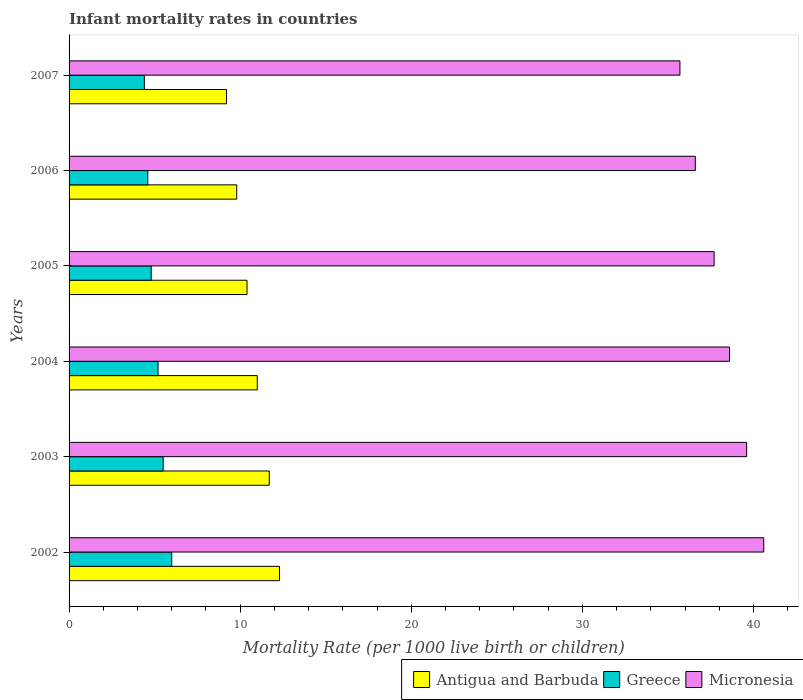Are the number of bars per tick equal to the number of legend labels?
Give a very brief answer. Yes. How many bars are there on the 1st tick from the bottom?
Give a very brief answer. 3. What is the label of the 2nd group of bars from the top?
Give a very brief answer. 2006. In how many cases, is the number of bars for a given year not equal to the number of legend labels?
Make the answer very short. 0. Across all years, what is the minimum infant mortality rate in Micronesia?
Offer a very short reply. 35.7. What is the total infant mortality rate in Greece in the graph?
Your answer should be compact. 30.5. What is the difference between the infant mortality rate in Micronesia in 2003 and that in 2005?
Your response must be concise. 1.9. What is the difference between the infant mortality rate in Antigua and Barbuda in 2004 and the infant mortality rate in Micronesia in 2002?
Provide a short and direct response. -29.6. What is the average infant mortality rate in Greece per year?
Your response must be concise. 5.08. In the year 2002, what is the difference between the infant mortality rate in Antigua and Barbuda and infant mortality rate in Greece?
Your response must be concise. 6.3. In how many years, is the infant mortality rate in Antigua and Barbuda greater than 2 ?
Provide a short and direct response. 6. What is the ratio of the infant mortality rate in Micronesia in 2004 to that in 2005?
Provide a succinct answer. 1.02. Is the difference between the infant mortality rate in Antigua and Barbuda in 2003 and 2006 greater than the difference between the infant mortality rate in Greece in 2003 and 2006?
Your answer should be compact. Yes. What is the difference between the highest and the second highest infant mortality rate in Greece?
Your answer should be very brief. 0.5. What is the difference between the highest and the lowest infant mortality rate in Greece?
Offer a terse response. 1.6. What does the 1st bar from the top in 2002 represents?
Give a very brief answer. Micronesia. What does the 3rd bar from the bottom in 2005 represents?
Your answer should be very brief. Micronesia. How many bars are there?
Give a very brief answer. 18. How many years are there in the graph?
Give a very brief answer. 6. What is the difference between two consecutive major ticks on the X-axis?
Make the answer very short. 10. Are the values on the major ticks of X-axis written in scientific E-notation?
Ensure brevity in your answer.  No. Does the graph contain any zero values?
Provide a succinct answer. No. Does the graph contain grids?
Your response must be concise. No. How many legend labels are there?
Provide a short and direct response. 3. How are the legend labels stacked?
Keep it short and to the point. Horizontal. What is the title of the graph?
Ensure brevity in your answer.  Infant mortality rates in countries. Does "Qatar" appear as one of the legend labels in the graph?
Your answer should be very brief. No. What is the label or title of the X-axis?
Offer a very short reply. Mortality Rate (per 1000 live birth or children). What is the Mortality Rate (per 1000 live birth or children) in Antigua and Barbuda in 2002?
Your answer should be very brief. 12.3. What is the Mortality Rate (per 1000 live birth or children) of Micronesia in 2002?
Provide a short and direct response. 40.6. What is the Mortality Rate (per 1000 live birth or children) in Antigua and Barbuda in 2003?
Your answer should be very brief. 11.7. What is the Mortality Rate (per 1000 live birth or children) of Greece in 2003?
Keep it short and to the point. 5.5. What is the Mortality Rate (per 1000 live birth or children) of Micronesia in 2003?
Make the answer very short. 39.6. What is the Mortality Rate (per 1000 live birth or children) of Antigua and Barbuda in 2004?
Offer a very short reply. 11. What is the Mortality Rate (per 1000 live birth or children) of Micronesia in 2004?
Provide a succinct answer. 38.6. What is the Mortality Rate (per 1000 live birth or children) of Antigua and Barbuda in 2005?
Provide a short and direct response. 10.4. What is the Mortality Rate (per 1000 live birth or children) of Greece in 2005?
Provide a succinct answer. 4.8. What is the Mortality Rate (per 1000 live birth or children) in Micronesia in 2005?
Give a very brief answer. 37.7. What is the Mortality Rate (per 1000 live birth or children) in Micronesia in 2006?
Provide a short and direct response. 36.6. What is the Mortality Rate (per 1000 live birth or children) in Antigua and Barbuda in 2007?
Offer a very short reply. 9.2. What is the Mortality Rate (per 1000 live birth or children) in Greece in 2007?
Ensure brevity in your answer.  4.4. What is the Mortality Rate (per 1000 live birth or children) in Micronesia in 2007?
Give a very brief answer. 35.7. Across all years, what is the maximum Mortality Rate (per 1000 live birth or children) in Antigua and Barbuda?
Offer a very short reply. 12.3. Across all years, what is the maximum Mortality Rate (per 1000 live birth or children) in Greece?
Offer a terse response. 6. Across all years, what is the maximum Mortality Rate (per 1000 live birth or children) of Micronesia?
Provide a succinct answer. 40.6. Across all years, what is the minimum Mortality Rate (per 1000 live birth or children) in Micronesia?
Ensure brevity in your answer.  35.7. What is the total Mortality Rate (per 1000 live birth or children) of Antigua and Barbuda in the graph?
Provide a short and direct response. 64.4. What is the total Mortality Rate (per 1000 live birth or children) in Greece in the graph?
Your response must be concise. 30.5. What is the total Mortality Rate (per 1000 live birth or children) in Micronesia in the graph?
Offer a terse response. 228.8. What is the difference between the Mortality Rate (per 1000 live birth or children) of Antigua and Barbuda in 2002 and that in 2003?
Your answer should be compact. 0.6. What is the difference between the Mortality Rate (per 1000 live birth or children) of Greece in 2002 and that in 2003?
Offer a very short reply. 0.5. What is the difference between the Mortality Rate (per 1000 live birth or children) of Micronesia in 2002 and that in 2003?
Your response must be concise. 1. What is the difference between the Mortality Rate (per 1000 live birth or children) in Greece in 2002 and that in 2004?
Give a very brief answer. 0.8. What is the difference between the Mortality Rate (per 1000 live birth or children) of Micronesia in 2002 and that in 2004?
Give a very brief answer. 2. What is the difference between the Mortality Rate (per 1000 live birth or children) in Antigua and Barbuda in 2002 and that in 2005?
Provide a short and direct response. 1.9. What is the difference between the Mortality Rate (per 1000 live birth or children) in Greece in 2002 and that in 2006?
Keep it short and to the point. 1.4. What is the difference between the Mortality Rate (per 1000 live birth or children) of Micronesia in 2002 and that in 2006?
Offer a very short reply. 4. What is the difference between the Mortality Rate (per 1000 live birth or children) of Antigua and Barbuda in 2002 and that in 2007?
Ensure brevity in your answer.  3.1. What is the difference between the Mortality Rate (per 1000 live birth or children) in Greece in 2002 and that in 2007?
Offer a terse response. 1.6. What is the difference between the Mortality Rate (per 1000 live birth or children) of Micronesia in 2002 and that in 2007?
Offer a terse response. 4.9. What is the difference between the Mortality Rate (per 1000 live birth or children) in Greece in 2003 and that in 2004?
Give a very brief answer. 0.3. What is the difference between the Mortality Rate (per 1000 live birth or children) of Micronesia in 2003 and that in 2004?
Provide a succinct answer. 1. What is the difference between the Mortality Rate (per 1000 live birth or children) of Greece in 2003 and that in 2007?
Give a very brief answer. 1.1. What is the difference between the Mortality Rate (per 1000 live birth or children) in Micronesia in 2004 and that in 2005?
Ensure brevity in your answer.  0.9. What is the difference between the Mortality Rate (per 1000 live birth or children) of Antigua and Barbuda in 2004 and that in 2006?
Make the answer very short. 1.2. What is the difference between the Mortality Rate (per 1000 live birth or children) of Micronesia in 2004 and that in 2006?
Make the answer very short. 2. What is the difference between the Mortality Rate (per 1000 live birth or children) of Antigua and Barbuda in 2004 and that in 2007?
Ensure brevity in your answer.  1.8. What is the difference between the Mortality Rate (per 1000 live birth or children) in Micronesia in 2004 and that in 2007?
Make the answer very short. 2.9. What is the difference between the Mortality Rate (per 1000 live birth or children) in Antigua and Barbuda in 2005 and that in 2006?
Your answer should be compact. 0.6. What is the difference between the Mortality Rate (per 1000 live birth or children) in Micronesia in 2005 and that in 2006?
Offer a terse response. 1.1. What is the difference between the Mortality Rate (per 1000 live birth or children) in Antigua and Barbuda in 2006 and that in 2007?
Give a very brief answer. 0.6. What is the difference between the Mortality Rate (per 1000 live birth or children) in Greece in 2006 and that in 2007?
Provide a succinct answer. 0.2. What is the difference between the Mortality Rate (per 1000 live birth or children) of Micronesia in 2006 and that in 2007?
Your response must be concise. 0.9. What is the difference between the Mortality Rate (per 1000 live birth or children) of Antigua and Barbuda in 2002 and the Mortality Rate (per 1000 live birth or children) of Greece in 2003?
Your answer should be compact. 6.8. What is the difference between the Mortality Rate (per 1000 live birth or children) of Antigua and Barbuda in 2002 and the Mortality Rate (per 1000 live birth or children) of Micronesia in 2003?
Ensure brevity in your answer.  -27.3. What is the difference between the Mortality Rate (per 1000 live birth or children) of Greece in 2002 and the Mortality Rate (per 1000 live birth or children) of Micronesia in 2003?
Provide a short and direct response. -33.6. What is the difference between the Mortality Rate (per 1000 live birth or children) in Antigua and Barbuda in 2002 and the Mortality Rate (per 1000 live birth or children) in Micronesia in 2004?
Provide a short and direct response. -26.3. What is the difference between the Mortality Rate (per 1000 live birth or children) in Greece in 2002 and the Mortality Rate (per 1000 live birth or children) in Micronesia in 2004?
Your answer should be very brief. -32.6. What is the difference between the Mortality Rate (per 1000 live birth or children) in Antigua and Barbuda in 2002 and the Mortality Rate (per 1000 live birth or children) in Greece in 2005?
Your answer should be compact. 7.5. What is the difference between the Mortality Rate (per 1000 live birth or children) in Antigua and Barbuda in 2002 and the Mortality Rate (per 1000 live birth or children) in Micronesia in 2005?
Make the answer very short. -25.4. What is the difference between the Mortality Rate (per 1000 live birth or children) of Greece in 2002 and the Mortality Rate (per 1000 live birth or children) of Micronesia in 2005?
Provide a short and direct response. -31.7. What is the difference between the Mortality Rate (per 1000 live birth or children) in Antigua and Barbuda in 2002 and the Mortality Rate (per 1000 live birth or children) in Micronesia in 2006?
Give a very brief answer. -24.3. What is the difference between the Mortality Rate (per 1000 live birth or children) of Greece in 2002 and the Mortality Rate (per 1000 live birth or children) of Micronesia in 2006?
Give a very brief answer. -30.6. What is the difference between the Mortality Rate (per 1000 live birth or children) of Antigua and Barbuda in 2002 and the Mortality Rate (per 1000 live birth or children) of Greece in 2007?
Make the answer very short. 7.9. What is the difference between the Mortality Rate (per 1000 live birth or children) in Antigua and Barbuda in 2002 and the Mortality Rate (per 1000 live birth or children) in Micronesia in 2007?
Make the answer very short. -23.4. What is the difference between the Mortality Rate (per 1000 live birth or children) of Greece in 2002 and the Mortality Rate (per 1000 live birth or children) of Micronesia in 2007?
Keep it short and to the point. -29.7. What is the difference between the Mortality Rate (per 1000 live birth or children) in Antigua and Barbuda in 2003 and the Mortality Rate (per 1000 live birth or children) in Micronesia in 2004?
Your answer should be very brief. -26.9. What is the difference between the Mortality Rate (per 1000 live birth or children) in Greece in 2003 and the Mortality Rate (per 1000 live birth or children) in Micronesia in 2004?
Your answer should be very brief. -33.1. What is the difference between the Mortality Rate (per 1000 live birth or children) in Greece in 2003 and the Mortality Rate (per 1000 live birth or children) in Micronesia in 2005?
Make the answer very short. -32.2. What is the difference between the Mortality Rate (per 1000 live birth or children) in Antigua and Barbuda in 2003 and the Mortality Rate (per 1000 live birth or children) in Greece in 2006?
Offer a terse response. 7.1. What is the difference between the Mortality Rate (per 1000 live birth or children) in Antigua and Barbuda in 2003 and the Mortality Rate (per 1000 live birth or children) in Micronesia in 2006?
Keep it short and to the point. -24.9. What is the difference between the Mortality Rate (per 1000 live birth or children) of Greece in 2003 and the Mortality Rate (per 1000 live birth or children) of Micronesia in 2006?
Provide a succinct answer. -31.1. What is the difference between the Mortality Rate (per 1000 live birth or children) in Antigua and Barbuda in 2003 and the Mortality Rate (per 1000 live birth or children) in Micronesia in 2007?
Make the answer very short. -24. What is the difference between the Mortality Rate (per 1000 live birth or children) in Greece in 2003 and the Mortality Rate (per 1000 live birth or children) in Micronesia in 2007?
Provide a short and direct response. -30.2. What is the difference between the Mortality Rate (per 1000 live birth or children) in Antigua and Barbuda in 2004 and the Mortality Rate (per 1000 live birth or children) in Micronesia in 2005?
Provide a short and direct response. -26.7. What is the difference between the Mortality Rate (per 1000 live birth or children) in Greece in 2004 and the Mortality Rate (per 1000 live birth or children) in Micronesia in 2005?
Keep it short and to the point. -32.5. What is the difference between the Mortality Rate (per 1000 live birth or children) of Antigua and Barbuda in 2004 and the Mortality Rate (per 1000 live birth or children) of Micronesia in 2006?
Offer a terse response. -25.6. What is the difference between the Mortality Rate (per 1000 live birth or children) of Greece in 2004 and the Mortality Rate (per 1000 live birth or children) of Micronesia in 2006?
Your response must be concise. -31.4. What is the difference between the Mortality Rate (per 1000 live birth or children) of Antigua and Barbuda in 2004 and the Mortality Rate (per 1000 live birth or children) of Greece in 2007?
Your answer should be very brief. 6.6. What is the difference between the Mortality Rate (per 1000 live birth or children) of Antigua and Barbuda in 2004 and the Mortality Rate (per 1000 live birth or children) of Micronesia in 2007?
Offer a terse response. -24.7. What is the difference between the Mortality Rate (per 1000 live birth or children) in Greece in 2004 and the Mortality Rate (per 1000 live birth or children) in Micronesia in 2007?
Offer a very short reply. -30.5. What is the difference between the Mortality Rate (per 1000 live birth or children) in Antigua and Barbuda in 2005 and the Mortality Rate (per 1000 live birth or children) in Micronesia in 2006?
Give a very brief answer. -26.2. What is the difference between the Mortality Rate (per 1000 live birth or children) of Greece in 2005 and the Mortality Rate (per 1000 live birth or children) of Micronesia in 2006?
Offer a very short reply. -31.8. What is the difference between the Mortality Rate (per 1000 live birth or children) in Antigua and Barbuda in 2005 and the Mortality Rate (per 1000 live birth or children) in Micronesia in 2007?
Offer a terse response. -25.3. What is the difference between the Mortality Rate (per 1000 live birth or children) of Greece in 2005 and the Mortality Rate (per 1000 live birth or children) of Micronesia in 2007?
Give a very brief answer. -30.9. What is the difference between the Mortality Rate (per 1000 live birth or children) of Antigua and Barbuda in 2006 and the Mortality Rate (per 1000 live birth or children) of Micronesia in 2007?
Offer a terse response. -25.9. What is the difference between the Mortality Rate (per 1000 live birth or children) of Greece in 2006 and the Mortality Rate (per 1000 live birth or children) of Micronesia in 2007?
Keep it short and to the point. -31.1. What is the average Mortality Rate (per 1000 live birth or children) in Antigua and Barbuda per year?
Provide a short and direct response. 10.73. What is the average Mortality Rate (per 1000 live birth or children) of Greece per year?
Keep it short and to the point. 5.08. What is the average Mortality Rate (per 1000 live birth or children) in Micronesia per year?
Your answer should be very brief. 38.13. In the year 2002, what is the difference between the Mortality Rate (per 1000 live birth or children) in Antigua and Barbuda and Mortality Rate (per 1000 live birth or children) in Micronesia?
Give a very brief answer. -28.3. In the year 2002, what is the difference between the Mortality Rate (per 1000 live birth or children) in Greece and Mortality Rate (per 1000 live birth or children) in Micronesia?
Ensure brevity in your answer.  -34.6. In the year 2003, what is the difference between the Mortality Rate (per 1000 live birth or children) of Antigua and Barbuda and Mortality Rate (per 1000 live birth or children) of Greece?
Make the answer very short. 6.2. In the year 2003, what is the difference between the Mortality Rate (per 1000 live birth or children) in Antigua and Barbuda and Mortality Rate (per 1000 live birth or children) in Micronesia?
Offer a very short reply. -27.9. In the year 2003, what is the difference between the Mortality Rate (per 1000 live birth or children) of Greece and Mortality Rate (per 1000 live birth or children) of Micronesia?
Give a very brief answer. -34.1. In the year 2004, what is the difference between the Mortality Rate (per 1000 live birth or children) of Antigua and Barbuda and Mortality Rate (per 1000 live birth or children) of Greece?
Ensure brevity in your answer.  5.8. In the year 2004, what is the difference between the Mortality Rate (per 1000 live birth or children) of Antigua and Barbuda and Mortality Rate (per 1000 live birth or children) of Micronesia?
Offer a very short reply. -27.6. In the year 2004, what is the difference between the Mortality Rate (per 1000 live birth or children) of Greece and Mortality Rate (per 1000 live birth or children) of Micronesia?
Ensure brevity in your answer.  -33.4. In the year 2005, what is the difference between the Mortality Rate (per 1000 live birth or children) of Antigua and Barbuda and Mortality Rate (per 1000 live birth or children) of Micronesia?
Your answer should be very brief. -27.3. In the year 2005, what is the difference between the Mortality Rate (per 1000 live birth or children) in Greece and Mortality Rate (per 1000 live birth or children) in Micronesia?
Make the answer very short. -32.9. In the year 2006, what is the difference between the Mortality Rate (per 1000 live birth or children) of Antigua and Barbuda and Mortality Rate (per 1000 live birth or children) of Greece?
Your response must be concise. 5.2. In the year 2006, what is the difference between the Mortality Rate (per 1000 live birth or children) of Antigua and Barbuda and Mortality Rate (per 1000 live birth or children) of Micronesia?
Your answer should be compact. -26.8. In the year 2006, what is the difference between the Mortality Rate (per 1000 live birth or children) in Greece and Mortality Rate (per 1000 live birth or children) in Micronesia?
Your answer should be very brief. -32. In the year 2007, what is the difference between the Mortality Rate (per 1000 live birth or children) of Antigua and Barbuda and Mortality Rate (per 1000 live birth or children) of Micronesia?
Make the answer very short. -26.5. In the year 2007, what is the difference between the Mortality Rate (per 1000 live birth or children) in Greece and Mortality Rate (per 1000 live birth or children) in Micronesia?
Your response must be concise. -31.3. What is the ratio of the Mortality Rate (per 1000 live birth or children) of Antigua and Barbuda in 2002 to that in 2003?
Your answer should be compact. 1.05. What is the ratio of the Mortality Rate (per 1000 live birth or children) of Micronesia in 2002 to that in 2003?
Make the answer very short. 1.03. What is the ratio of the Mortality Rate (per 1000 live birth or children) in Antigua and Barbuda in 2002 to that in 2004?
Make the answer very short. 1.12. What is the ratio of the Mortality Rate (per 1000 live birth or children) of Greece in 2002 to that in 2004?
Your response must be concise. 1.15. What is the ratio of the Mortality Rate (per 1000 live birth or children) in Micronesia in 2002 to that in 2004?
Offer a very short reply. 1.05. What is the ratio of the Mortality Rate (per 1000 live birth or children) of Antigua and Barbuda in 2002 to that in 2005?
Provide a short and direct response. 1.18. What is the ratio of the Mortality Rate (per 1000 live birth or children) in Antigua and Barbuda in 2002 to that in 2006?
Give a very brief answer. 1.26. What is the ratio of the Mortality Rate (per 1000 live birth or children) of Greece in 2002 to that in 2006?
Provide a succinct answer. 1.3. What is the ratio of the Mortality Rate (per 1000 live birth or children) in Micronesia in 2002 to that in 2006?
Offer a terse response. 1.11. What is the ratio of the Mortality Rate (per 1000 live birth or children) of Antigua and Barbuda in 2002 to that in 2007?
Your response must be concise. 1.34. What is the ratio of the Mortality Rate (per 1000 live birth or children) in Greece in 2002 to that in 2007?
Your answer should be very brief. 1.36. What is the ratio of the Mortality Rate (per 1000 live birth or children) of Micronesia in 2002 to that in 2007?
Your answer should be very brief. 1.14. What is the ratio of the Mortality Rate (per 1000 live birth or children) of Antigua and Barbuda in 2003 to that in 2004?
Your answer should be compact. 1.06. What is the ratio of the Mortality Rate (per 1000 live birth or children) of Greece in 2003 to that in 2004?
Offer a terse response. 1.06. What is the ratio of the Mortality Rate (per 1000 live birth or children) of Micronesia in 2003 to that in 2004?
Offer a very short reply. 1.03. What is the ratio of the Mortality Rate (per 1000 live birth or children) in Antigua and Barbuda in 2003 to that in 2005?
Make the answer very short. 1.12. What is the ratio of the Mortality Rate (per 1000 live birth or children) in Greece in 2003 to that in 2005?
Keep it short and to the point. 1.15. What is the ratio of the Mortality Rate (per 1000 live birth or children) in Micronesia in 2003 to that in 2005?
Your answer should be very brief. 1.05. What is the ratio of the Mortality Rate (per 1000 live birth or children) in Antigua and Barbuda in 2003 to that in 2006?
Give a very brief answer. 1.19. What is the ratio of the Mortality Rate (per 1000 live birth or children) in Greece in 2003 to that in 2006?
Offer a very short reply. 1.2. What is the ratio of the Mortality Rate (per 1000 live birth or children) of Micronesia in 2003 to that in 2006?
Keep it short and to the point. 1.08. What is the ratio of the Mortality Rate (per 1000 live birth or children) in Antigua and Barbuda in 2003 to that in 2007?
Keep it short and to the point. 1.27. What is the ratio of the Mortality Rate (per 1000 live birth or children) in Greece in 2003 to that in 2007?
Your response must be concise. 1.25. What is the ratio of the Mortality Rate (per 1000 live birth or children) of Micronesia in 2003 to that in 2007?
Your answer should be very brief. 1.11. What is the ratio of the Mortality Rate (per 1000 live birth or children) in Antigua and Barbuda in 2004 to that in 2005?
Make the answer very short. 1.06. What is the ratio of the Mortality Rate (per 1000 live birth or children) in Greece in 2004 to that in 2005?
Make the answer very short. 1.08. What is the ratio of the Mortality Rate (per 1000 live birth or children) in Micronesia in 2004 to that in 2005?
Offer a terse response. 1.02. What is the ratio of the Mortality Rate (per 1000 live birth or children) of Antigua and Barbuda in 2004 to that in 2006?
Your answer should be very brief. 1.12. What is the ratio of the Mortality Rate (per 1000 live birth or children) of Greece in 2004 to that in 2006?
Provide a short and direct response. 1.13. What is the ratio of the Mortality Rate (per 1000 live birth or children) of Micronesia in 2004 to that in 2006?
Provide a succinct answer. 1.05. What is the ratio of the Mortality Rate (per 1000 live birth or children) in Antigua and Barbuda in 2004 to that in 2007?
Provide a succinct answer. 1.2. What is the ratio of the Mortality Rate (per 1000 live birth or children) of Greece in 2004 to that in 2007?
Your response must be concise. 1.18. What is the ratio of the Mortality Rate (per 1000 live birth or children) of Micronesia in 2004 to that in 2007?
Keep it short and to the point. 1.08. What is the ratio of the Mortality Rate (per 1000 live birth or children) of Antigua and Barbuda in 2005 to that in 2006?
Make the answer very short. 1.06. What is the ratio of the Mortality Rate (per 1000 live birth or children) of Greece in 2005 to that in 2006?
Your answer should be compact. 1.04. What is the ratio of the Mortality Rate (per 1000 live birth or children) in Micronesia in 2005 to that in 2006?
Your answer should be compact. 1.03. What is the ratio of the Mortality Rate (per 1000 live birth or children) in Antigua and Barbuda in 2005 to that in 2007?
Keep it short and to the point. 1.13. What is the ratio of the Mortality Rate (per 1000 live birth or children) in Micronesia in 2005 to that in 2007?
Give a very brief answer. 1.06. What is the ratio of the Mortality Rate (per 1000 live birth or children) of Antigua and Barbuda in 2006 to that in 2007?
Provide a short and direct response. 1.07. What is the ratio of the Mortality Rate (per 1000 live birth or children) in Greece in 2006 to that in 2007?
Ensure brevity in your answer.  1.05. What is the ratio of the Mortality Rate (per 1000 live birth or children) of Micronesia in 2006 to that in 2007?
Your answer should be compact. 1.03. What is the difference between the highest and the second highest Mortality Rate (per 1000 live birth or children) in Greece?
Your answer should be very brief. 0.5. What is the difference between the highest and the second highest Mortality Rate (per 1000 live birth or children) in Micronesia?
Provide a short and direct response. 1. What is the difference between the highest and the lowest Mortality Rate (per 1000 live birth or children) in Antigua and Barbuda?
Offer a terse response. 3.1. What is the difference between the highest and the lowest Mortality Rate (per 1000 live birth or children) in Greece?
Ensure brevity in your answer.  1.6. What is the difference between the highest and the lowest Mortality Rate (per 1000 live birth or children) of Micronesia?
Your answer should be very brief. 4.9. 